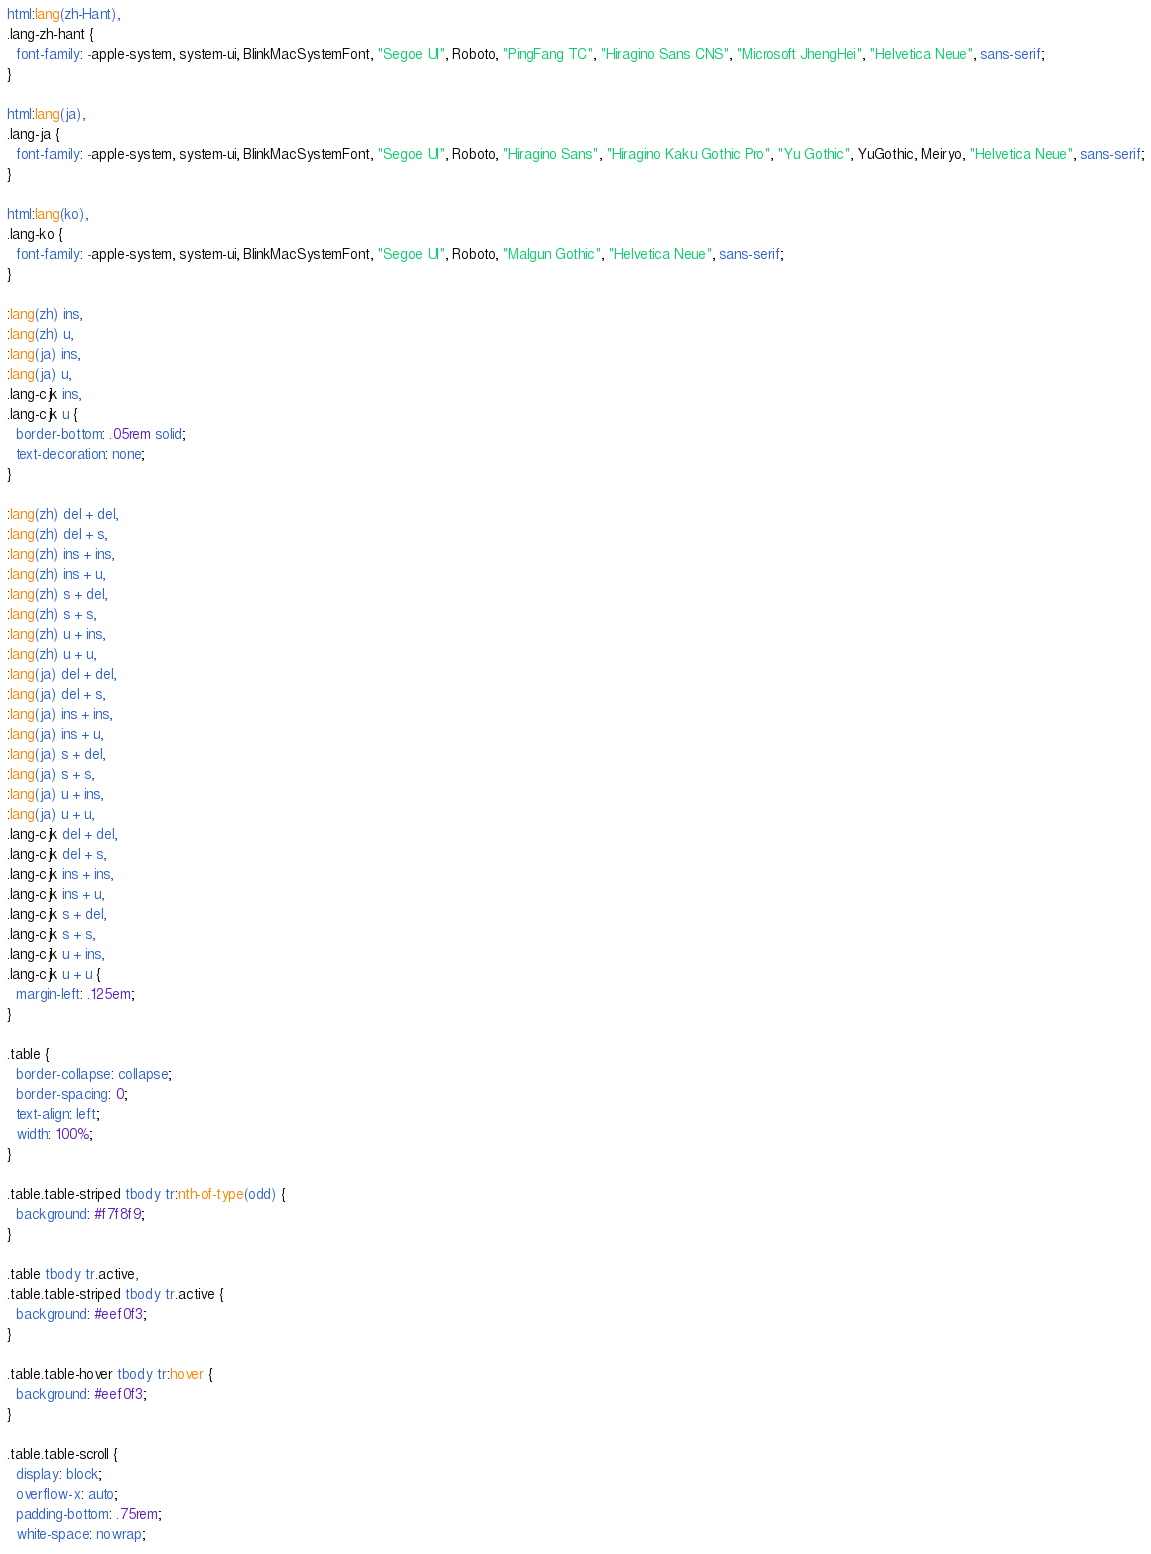Convert code to text. <code><loc_0><loc_0><loc_500><loc_500><_CSS_>html:lang(zh-Hant),
.lang-zh-hant {
  font-family: -apple-system, system-ui, BlinkMacSystemFont, "Segoe UI", Roboto, "PingFang TC", "Hiragino Sans CNS", "Microsoft JhengHei", "Helvetica Neue", sans-serif;
}

html:lang(ja),
.lang-ja {
  font-family: -apple-system, system-ui, BlinkMacSystemFont, "Segoe UI", Roboto, "Hiragino Sans", "Hiragino Kaku Gothic Pro", "Yu Gothic", YuGothic, Meiryo, "Helvetica Neue", sans-serif;
}

html:lang(ko),
.lang-ko {
  font-family: -apple-system, system-ui, BlinkMacSystemFont, "Segoe UI", Roboto, "Malgun Gothic", "Helvetica Neue", sans-serif;
}

:lang(zh) ins,
:lang(zh) u,
:lang(ja) ins,
:lang(ja) u,
.lang-cjk ins,
.lang-cjk u {
  border-bottom: .05rem solid;
  text-decoration: none;
}

:lang(zh) del + del,
:lang(zh) del + s,
:lang(zh) ins + ins,
:lang(zh) ins + u,
:lang(zh) s + del,
:lang(zh) s + s,
:lang(zh) u + ins,
:lang(zh) u + u,
:lang(ja) del + del,
:lang(ja) del + s,
:lang(ja) ins + ins,
:lang(ja) ins + u,
:lang(ja) s + del,
:lang(ja) s + s,
:lang(ja) u + ins,
:lang(ja) u + u,
.lang-cjk del + del,
.lang-cjk del + s,
.lang-cjk ins + ins,
.lang-cjk ins + u,
.lang-cjk s + del,
.lang-cjk s + s,
.lang-cjk u + ins,
.lang-cjk u + u {
  margin-left: .125em;
}

.table {
  border-collapse: collapse;
  border-spacing: 0;
  text-align: left; 
  width: 100%;
}

.table.table-striped tbody tr:nth-of-type(odd) {
  background: #f7f8f9;
}

.table tbody tr.active,
.table.table-striped tbody tr.active {
  background: #eef0f3;
}

.table.table-hover tbody tr:hover {
  background: #eef0f3;
}

.table.table-scroll {
  display: block;
  overflow-x: auto;
  padding-bottom: .75rem;
  white-space: nowrap;</code> 